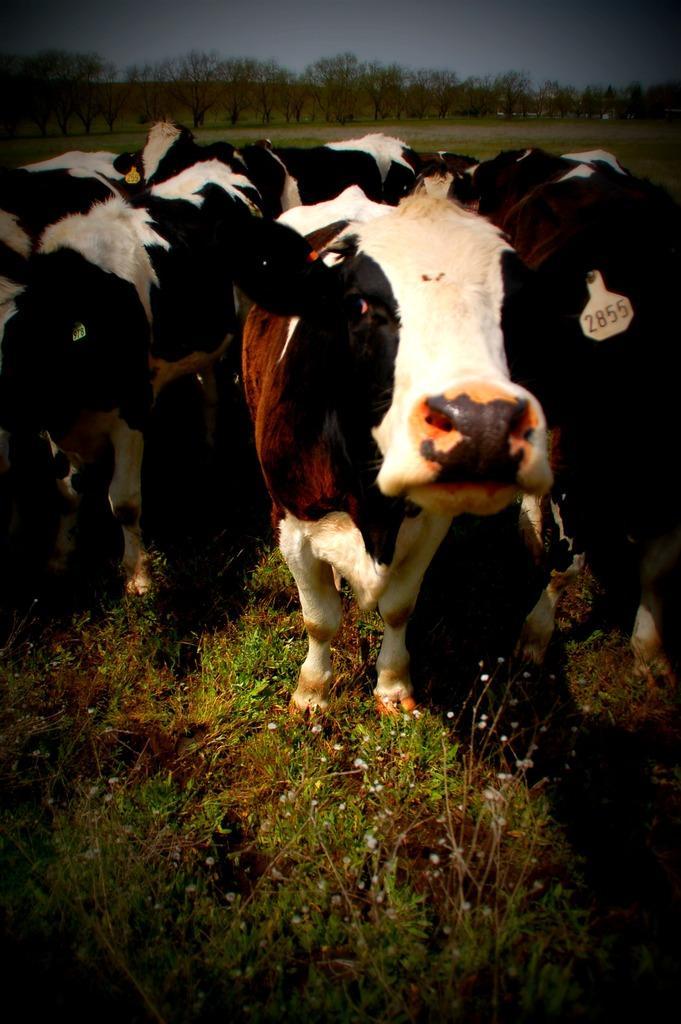Can you describe this image briefly? In the center of the image there are cows. At the bottom there is grass. In the background there are trees and sky. 